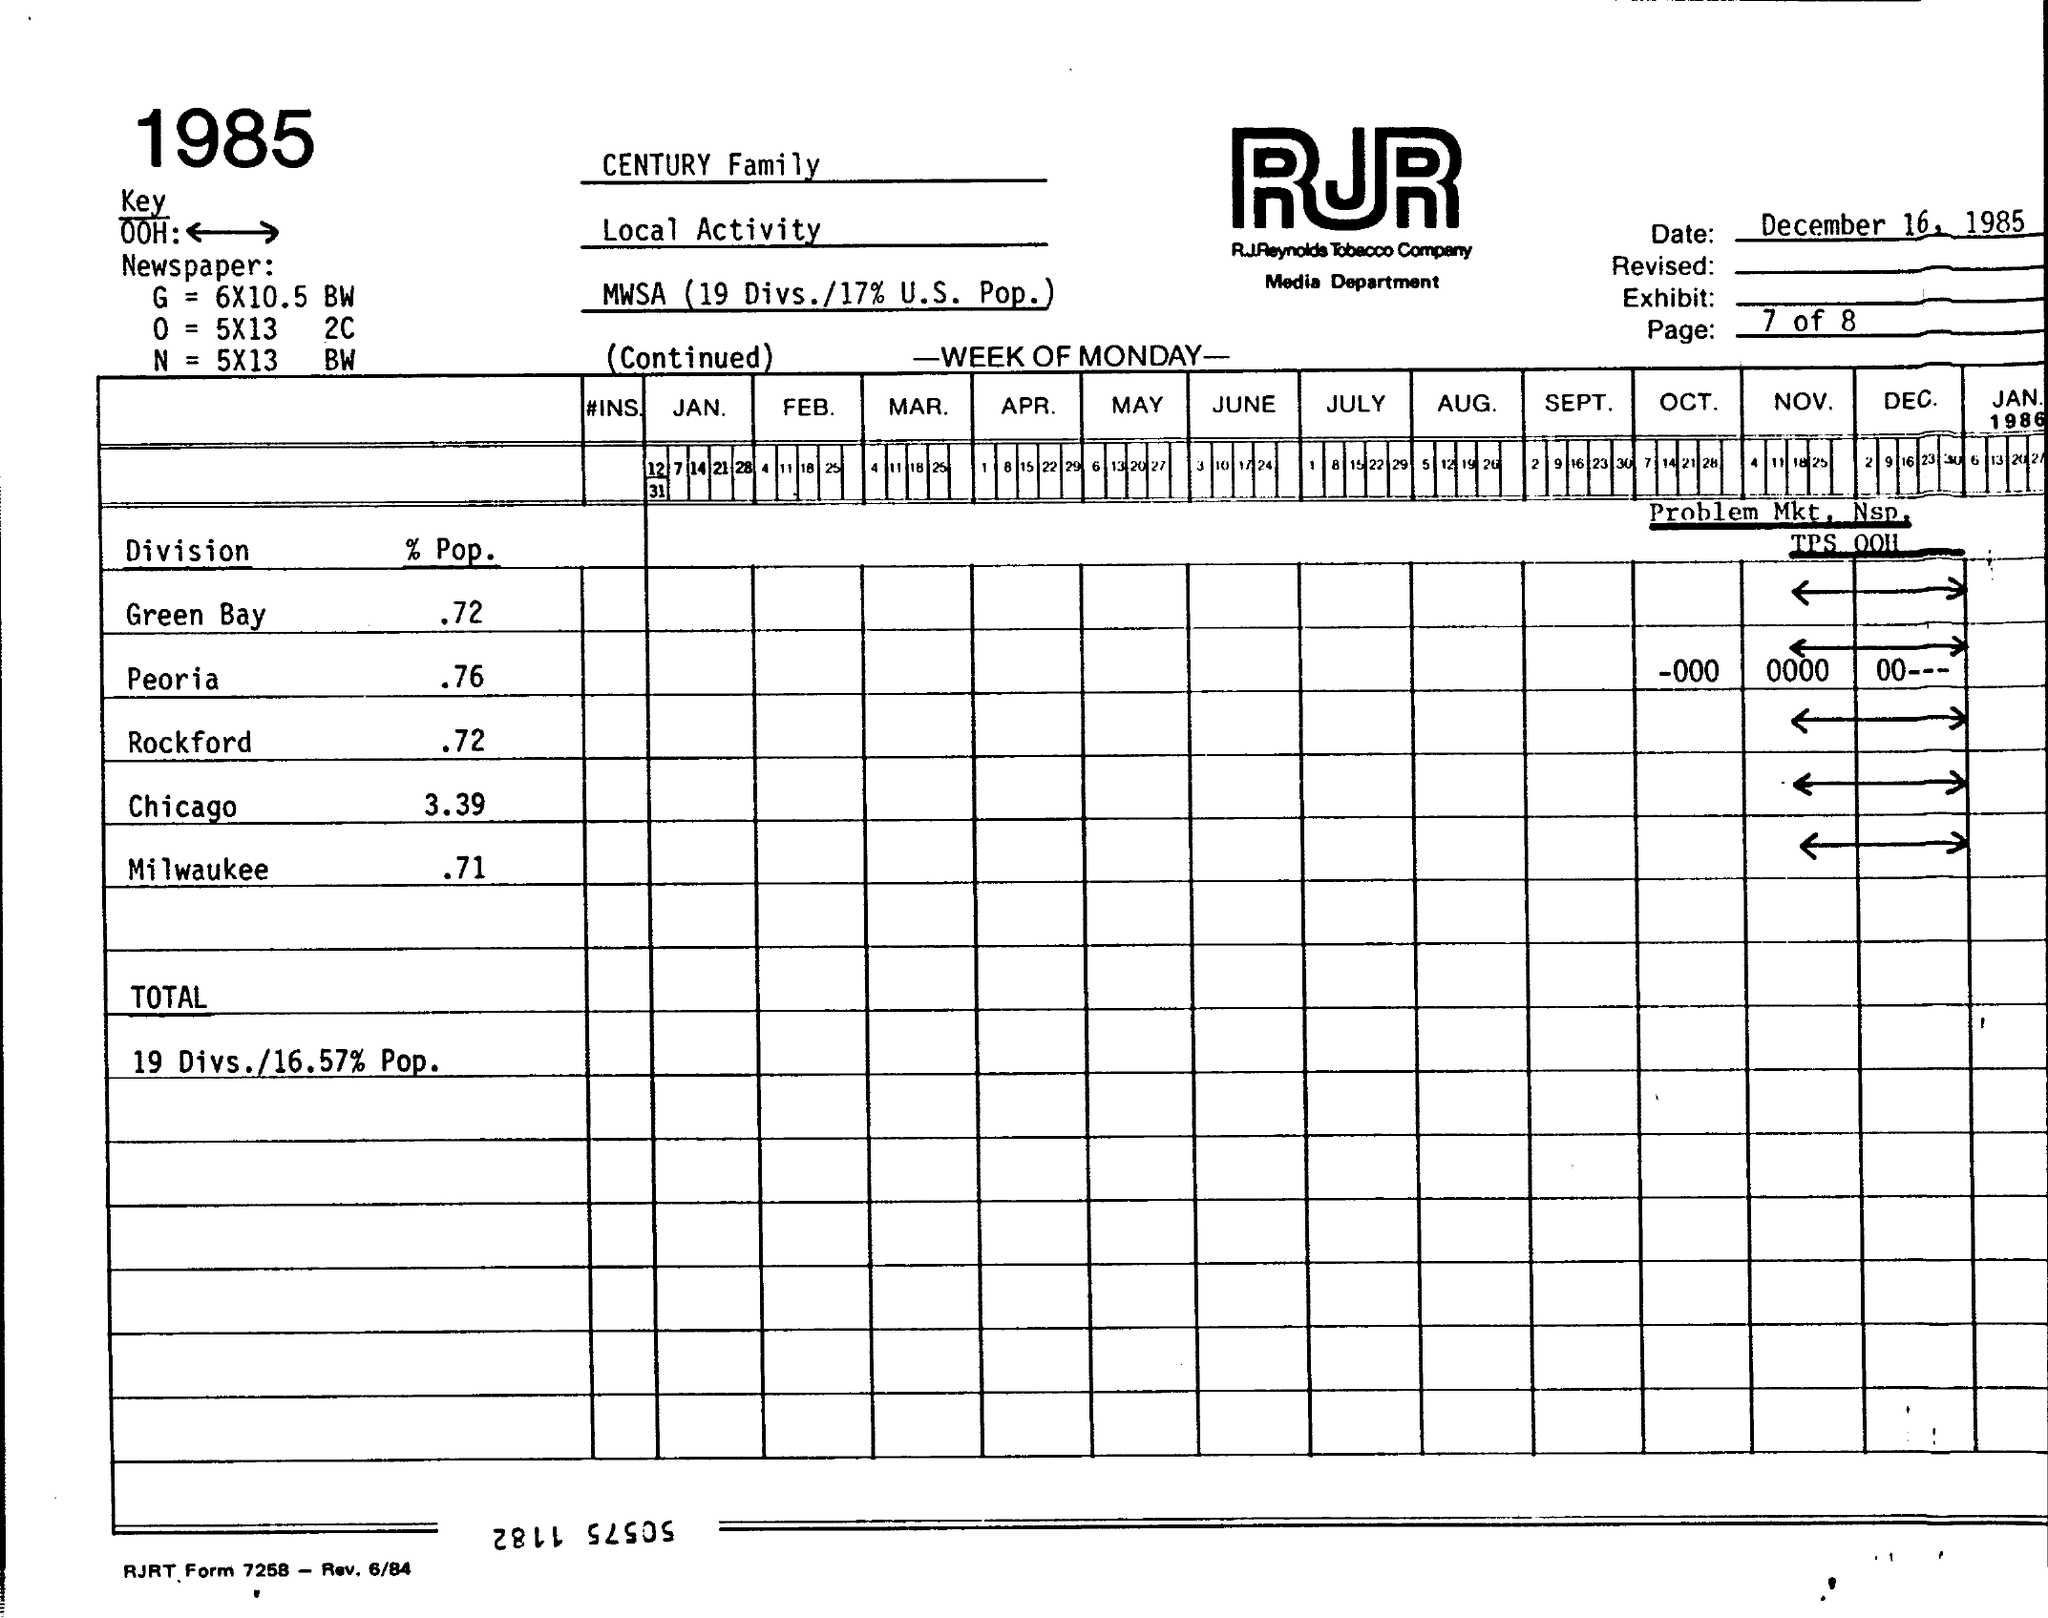What is the "Date" given at the top right corner of the page?
Offer a terse response. December 16, 1985. What is written below "RJR"?
Offer a terse response. RJREYNOLDS tobacco company. Which year is mentioned at left top of the page?
Give a very brief answer. 1985. What is the "% Pop." value for  "Green Bay" Division?
Give a very brief answer. .72. What is the "% Pop." value  for "Peoria" Division?
Ensure brevity in your answer.  .76. What is the "% Pop." value for "Rock ford" Division?
Make the answer very short. .72. What is the "% Pop." value for "Chicago" Division?
Provide a succinct answer. 3.39. What is the "% Pop." value  for "Milwaukee" Division?
Offer a very short reply. .71. What is the value of "TOTAL" provided?
Keep it short and to the point. 19 Divs./16.57 % Pop. 